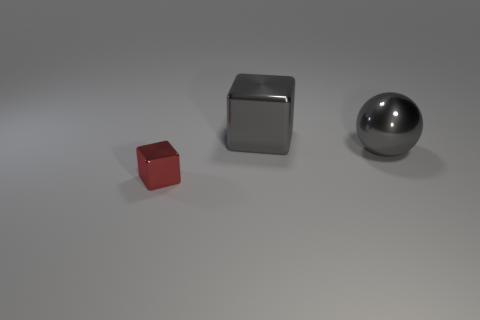Are there an equal number of tiny metallic things that are on the left side of the small metal block and blue metal balls? yes 